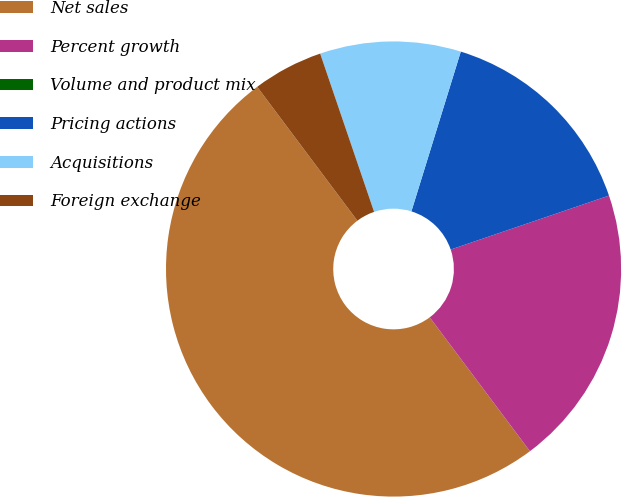Convert chart to OTSL. <chart><loc_0><loc_0><loc_500><loc_500><pie_chart><fcel>Net sales<fcel>Percent growth<fcel>Volume and product mix<fcel>Pricing actions<fcel>Acquisitions<fcel>Foreign exchange<nl><fcel>50.0%<fcel>20.0%<fcel>0.0%<fcel>15.0%<fcel>10.0%<fcel>5.0%<nl></chart> 